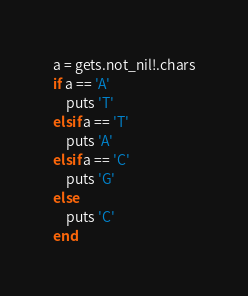Convert code to text. <code><loc_0><loc_0><loc_500><loc_500><_Crystal_>a = gets.not_nil!.chars
if a == 'A'
	puts 'T'
elsif a == 'T'
	puts 'A'
elsif a == 'C'
	puts 'G'
else
	puts 'C'
end</code> 